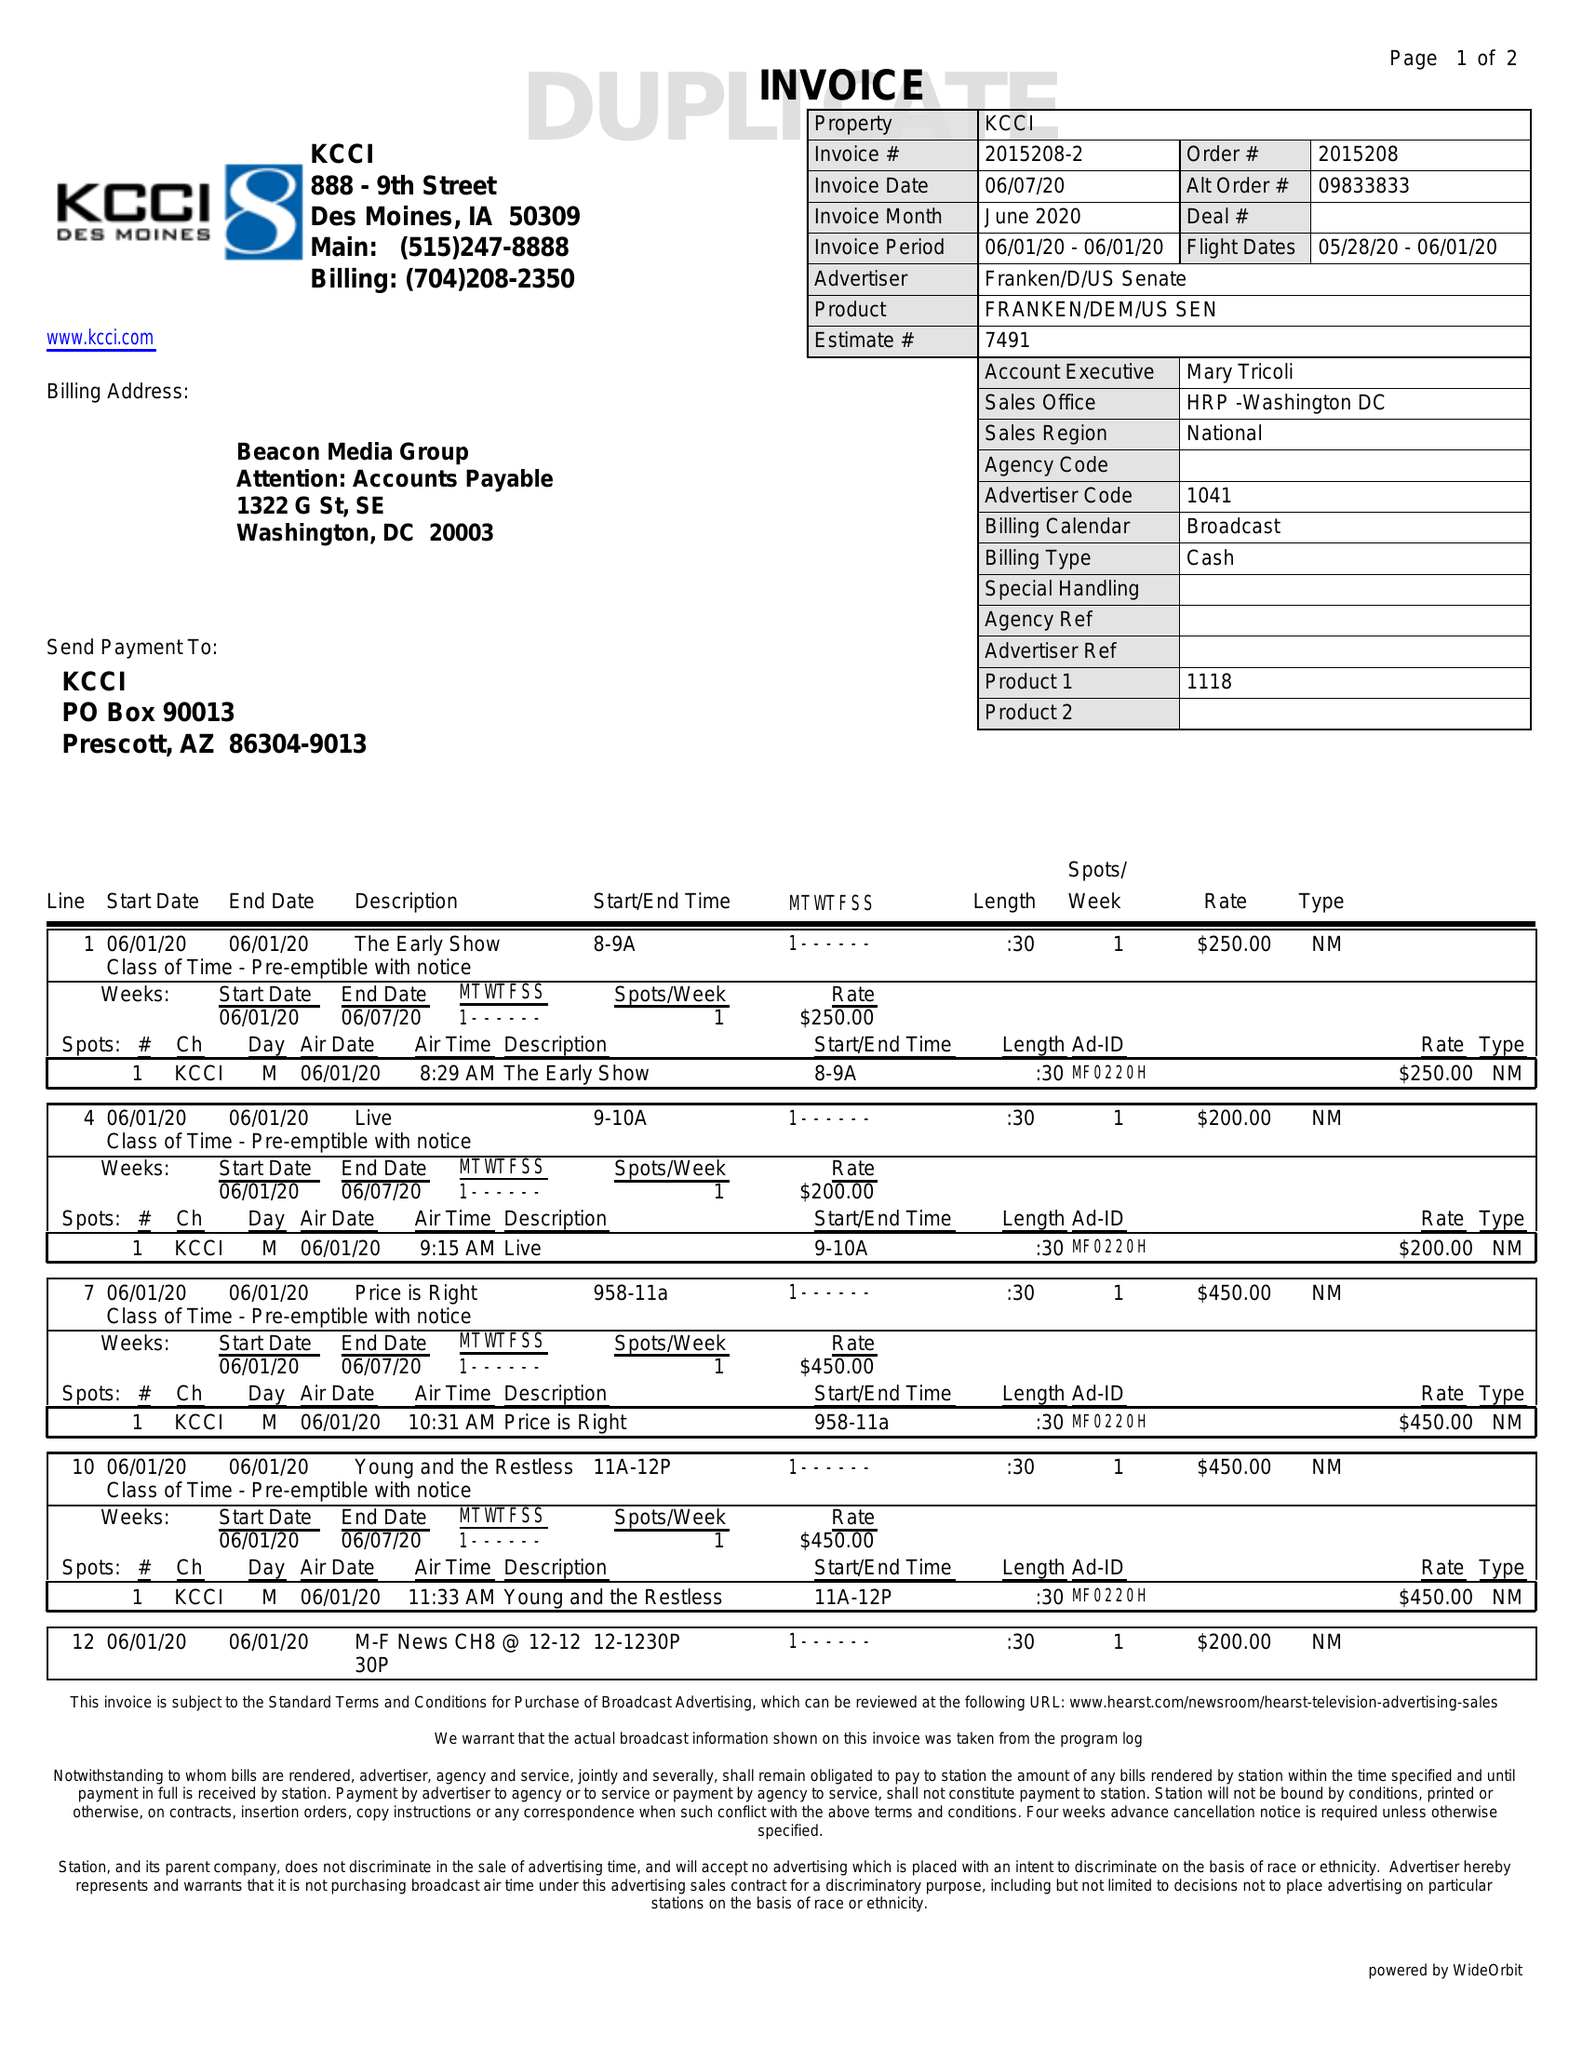What is the value for the flight_to?
Answer the question using a single word or phrase. 06/01/20 